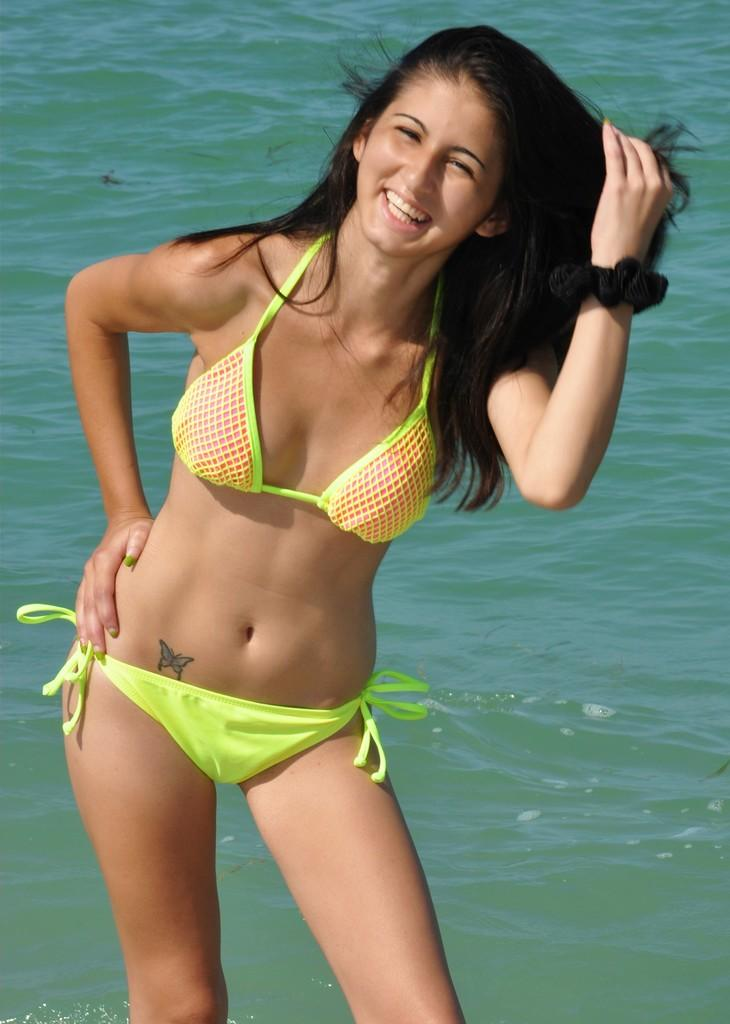Who is present in the image? There is a woman in the image. What is the woman doing in the image? The woman is standing in the water. What is the woman's facial expression in the image? The woman is smiling. What type of organization is the woman affiliated with in the image? There is no information about any organization in the image, as it only features a woman standing in the water and smiling. 